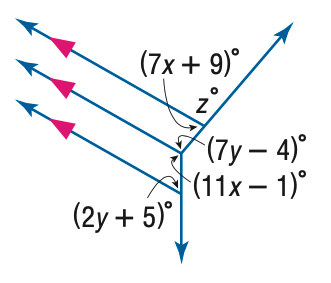Answer the mathemtical geometry problem and directly provide the correct option letter.
Question: Find z in the figure.
Choices: A: 27 B: 73 C: 89 D: 153 B 